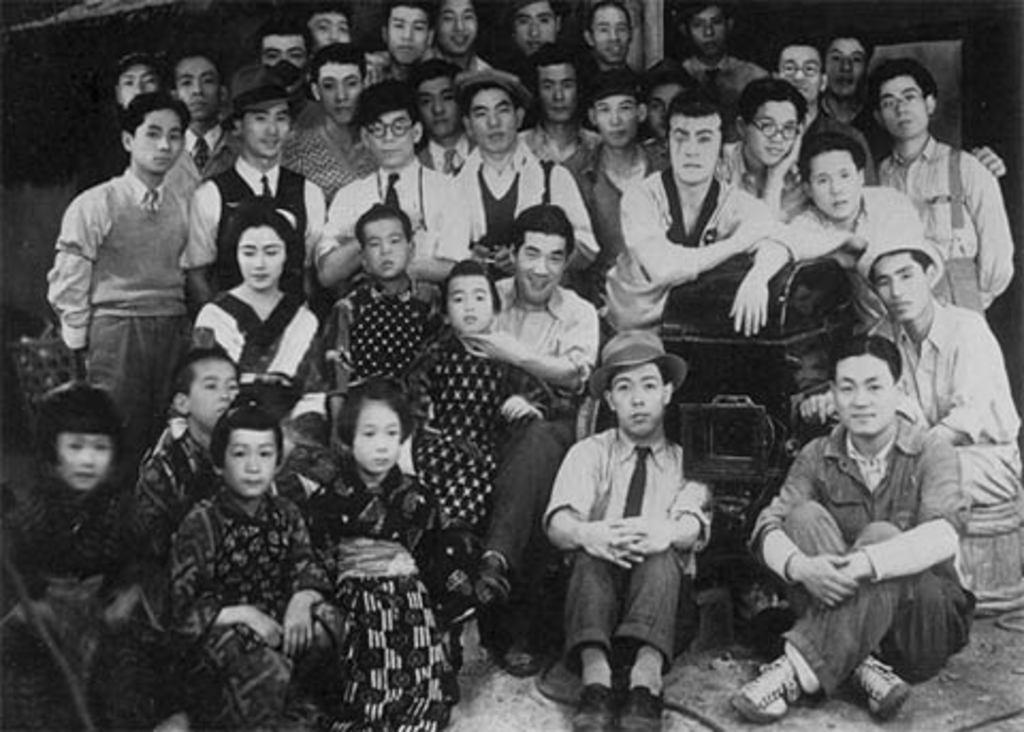What are the people in the image doing? There are persons sitting and standing in the image. What can be seen in the center of the image? There is an object in the center of the image. What is the color of the object in the image? The object is black in color. What type of cloth is draped over the secretary in the image? There is no secretary or cloth present in the image. What kind of ray is emitted from the object in the image? There is no ray emitted from the object in the image; it is simply a black object. 